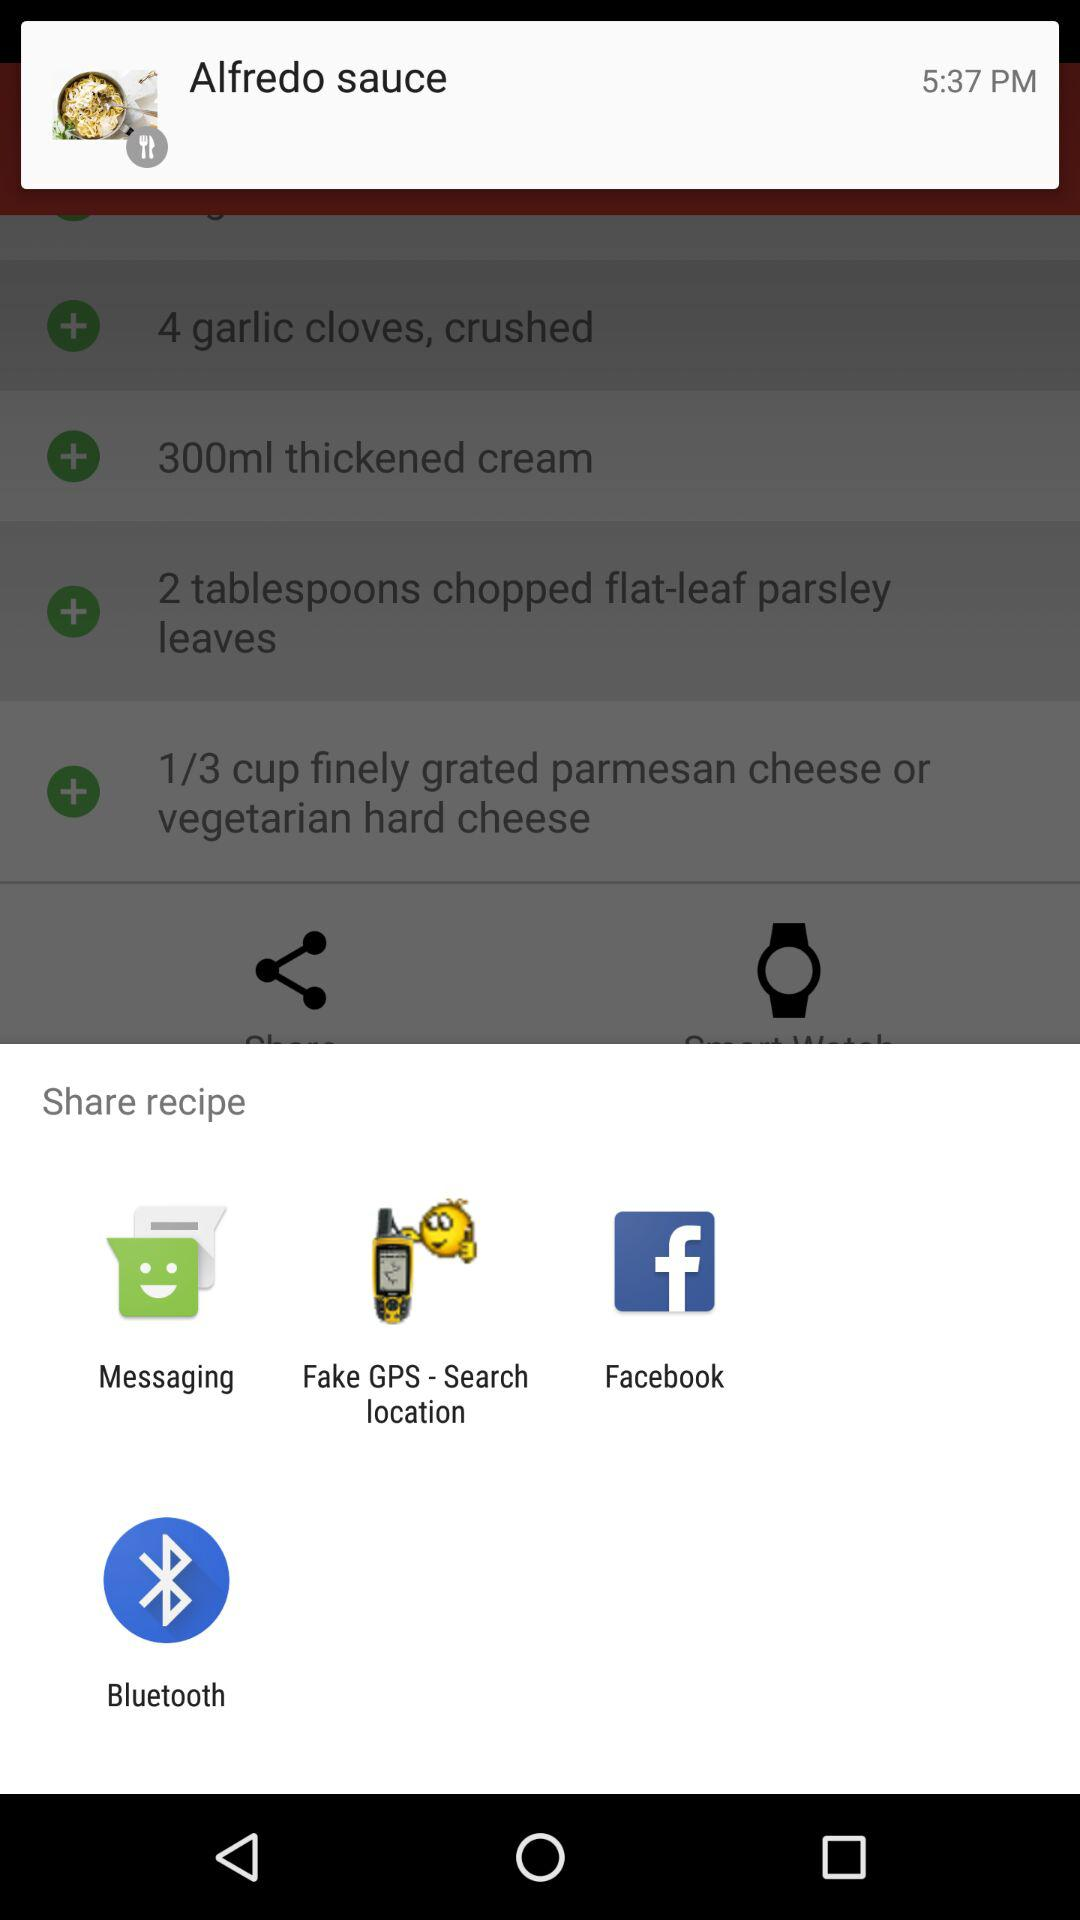What is the dish name? The dish name is "Alfredo sauce". 